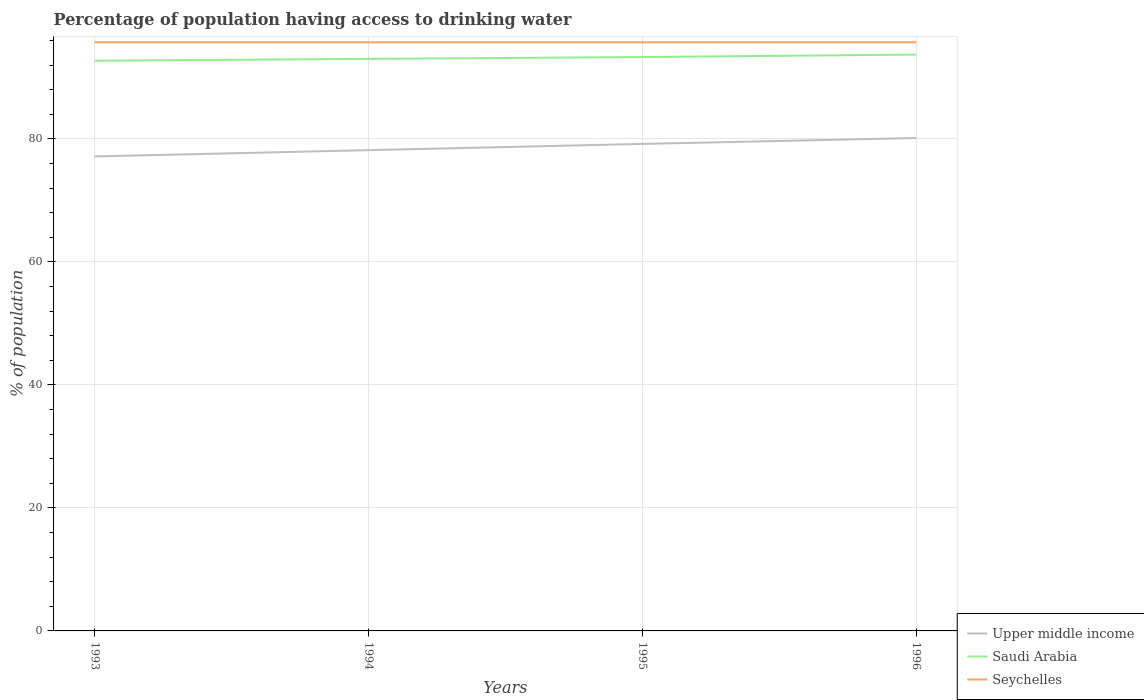How many different coloured lines are there?
Make the answer very short. 3. Across all years, what is the maximum percentage of population having access to drinking water in Saudi Arabia?
Provide a short and direct response. 92.7. What is the difference between the highest and the lowest percentage of population having access to drinking water in Upper middle income?
Provide a short and direct response. 2. What is the difference between two consecutive major ticks on the Y-axis?
Make the answer very short. 20. Does the graph contain any zero values?
Keep it short and to the point. No. Does the graph contain grids?
Ensure brevity in your answer.  Yes. Where does the legend appear in the graph?
Provide a short and direct response. Bottom right. How are the legend labels stacked?
Your answer should be compact. Vertical. What is the title of the graph?
Ensure brevity in your answer.  Percentage of population having access to drinking water. Does "Euro area" appear as one of the legend labels in the graph?
Provide a short and direct response. No. What is the label or title of the X-axis?
Offer a terse response. Years. What is the label or title of the Y-axis?
Your response must be concise. % of population. What is the % of population of Upper middle income in 1993?
Offer a terse response. 77.14. What is the % of population in Saudi Arabia in 1993?
Provide a short and direct response. 92.7. What is the % of population of Seychelles in 1993?
Give a very brief answer. 95.7. What is the % of population of Upper middle income in 1994?
Your response must be concise. 78.17. What is the % of population in Saudi Arabia in 1994?
Provide a short and direct response. 93. What is the % of population of Seychelles in 1994?
Your answer should be compact. 95.7. What is the % of population of Upper middle income in 1995?
Ensure brevity in your answer.  79.18. What is the % of population in Saudi Arabia in 1995?
Ensure brevity in your answer.  93.3. What is the % of population in Seychelles in 1995?
Provide a succinct answer. 95.7. What is the % of population in Upper middle income in 1996?
Provide a short and direct response. 80.14. What is the % of population in Saudi Arabia in 1996?
Your answer should be compact. 93.7. What is the % of population of Seychelles in 1996?
Offer a terse response. 95.7. Across all years, what is the maximum % of population of Upper middle income?
Give a very brief answer. 80.14. Across all years, what is the maximum % of population of Saudi Arabia?
Offer a terse response. 93.7. Across all years, what is the maximum % of population of Seychelles?
Your response must be concise. 95.7. Across all years, what is the minimum % of population of Upper middle income?
Provide a succinct answer. 77.14. Across all years, what is the minimum % of population in Saudi Arabia?
Your answer should be very brief. 92.7. Across all years, what is the minimum % of population in Seychelles?
Offer a terse response. 95.7. What is the total % of population in Upper middle income in the graph?
Offer a terse response. 314.62. What is the total % of population of Saudi Arabia in the graph?
Make the answer very short. 372.7. What is the total % of population in Seychelles in the graph?
Make the answer very short. 382.8. What is the difference between the % of population in Upper middle income in 1993 and that in 1994?
Your response must be concise. -1.03. What is the difference between the % of population of Seychelles in 1993 and that in 1994?
Provide a succinct answer. 0. What is the difference between the % of population of Upper middle income in 1993 and that in 1995?
Make the answer very short. -2.04. What is the difference between the % of population of Upper middle income in 1993 and that in 1996?
Offer a terse response. -3. What is the difference between the % of population in Seychelles in 1993 and that in 1996?
Provide a succinct answer. 0. What is the difference between the % of population of Upper middle income in 1994 and that in 1995?
Provide a succinct answer. -1.01. What is the difference between the % of population of Upper middle income in 1994 and that in 1996?
Provide a short and direct response. -1.97. What is the difference between the % of population in Saudi Arabia in 1994 and that in 1996?
Your answer should be compact. -0.7. What is the difference between the % of population in Upper middle income in 1995 and that in 1996?
Your answer should be very brief. -0.96. What is the difference between the % of population of Saudi Arabia in 1995 and that in 1996?
Ensure brevity in your answer.  -0.4. What is the difference between the % of population of Seychelles in 1995 and that in 1996?
Offer a terse response. 0. What is the difference between the % of population of Upper middle income in 1993 and the % of population of Saudi Arabia in 1994?
Ensure brevity in your answer.  -15.86. What is the difference between the % of population in Upper middle income in 1993 and the % of population in Seychelles in 1994?
Offer a very short reply. -18.56. What is the difference between the % of population of Saudi Arabia in 1993 and the % of population of Seychelles in 1994?
Make the answer very short. -3. What is the difference between the % of population in Upper middle income in 1993 and the % of population in Saudi Arabia in 1995?
Keep it short and to the point. -16.16. What is the difference between the % of population of Upper middle income in 1993 and the % of population of Seychelles in 1995?
Offer a terse response. -18.56. What is the difference between the % of population of Upper middle income in 1993 and the % of population of Saudi Arabia in 1996?
Ensure brevity in your answer.  -16.56. What is the difference between the % of population of Upper middle income in 1993 and the % of population of Seychelles in 1996?
Your answer should be compact. -18.56. What is the difference between the % of population in Saudi Arabia in 1993 and the % of population in Seychelles in 1996?
Make the answer very short. -3. What is the difference between the % of population in Upper middle income in 1994 and the % of population in Saudi Arabia in 1995?
Offer a terse response. -15.13. What is the difference between the % of population in Upper middle income in 1994 and the % of population in Seychelles in 1995?
Give a very brief answer. -17.53. What is the difference between the % of population of Upper middle income in 1994 and the % of population of Saudi Arabia in 1996?
Make the answer very short. -15.53. What is the difference between the % of population of Upper middle income in 1994 and the % of population of Seychelles in 1996?
Your response must be concise. -17.53. What is the difference between the % of population of Upper middle income in 1995 and the % of population of Saudi Arabia in 1996?
Make the answer very short. -14.52. What is the difference between the % of population in Upper middle income in 1995 and the % of population in Seychelles in 1996?
Provide a succinct answer. -16.52. What is the average % of population of Upper middle income per year?
Your response must be concise. 78.65. What is the average % of population in Saudi Arabia per year?
Ensure brevity in your answer.  93.17. What is the average % of population of Seychelles per year?
Your answer should be compact. 95.7. In the year 1993, what is the difference between the % of population in Upper middle income and % of population in Saudi Arabia?
Give a very brief answer. -15.56. In the year 1993, what is the difference between the % of population in Upper middle income and % of population in Seychelles?
Keep it short and to the point. -18.56. In the year 1994, what is the difference between the % of population in Upper middle income and % of population in Saudi Arabia?
Provide a short and direct response. -14.83. In the year 1994, what is the difference between the % of population in Upper middle income and % of population in Seychelles?
Your answer should be compact. -17.53. In the year 1995, what is the difference between the % of population in Upper middle income and % of population in Saudi Arabia?
Keep it short and to the point. -14.12. In the year 1995, what is the difference between the % of population in Upper middle income and % of population in Seychelles?
Make the answer very short. -16.52. In the year 1996, what is the difference between the % of population of Upper middle income and % of population of Saudi Arabia?
Make the answer very short. -13.56. In the year 1996, what is the difference between the % of population of Upper middle income and % of population of Seychelles?
Make the answer very short. -15.56. In the year 1996, what is the difference between the % of population of Saudi Arabia and % of population of Seychelles?
Provide a short and direct response. -2. What is the ratio of the % of population of Upper middle income in 1993 to that in 1994?
Your answer should be very brief. 0.99. What is the ratio of the % of population of Seychelles in 1993 to that in 1994?
Keep it short and to the point. 1. What is the ratio of the % of population of Upper middle income in 1993 to that in 1995?
Your response must be concise. 0.97. What is the ratio of the % of population in Saudi Arabia in 1993 to that in 1995?
Your answer should be compact. 0.99. What is the ratio of the % of population of Upper middle income in 1993 to that in 1996?
Offer a terse response. 0.96. What is the ratio of the % of population in Saudi Arabia in 1993 to that in 1996?
Give a very brief answer. 0.99. What is the ratio of the % of population in Upper middle income in 1994 to that in 1995?
Provide a succinct answer. 0.99. What is the ratio of the % of population of Seychelles in 1994 to that in 1995?
Offer a terse response. 1. What is the ratio of the % of population of Upper middle income in 1994 to that in 1996?
Give a very brief answer. 0.98. What is the ratio of the % of population of Saudi Arabia in 1994 to that in 1996?
Your response must be concise. 0.99. What is the ratio of the % of population of Seychelles in 1994 to that in 1996?
Ensure brevity in your answer.  1. What is the ratio of the % of population of Upper middle income in 1995 to that in 1996?
Provide a short and direct response. 0.99. What is the difference between the highest and the second highest % of population of Upper middle income?
Keep it short and to the point. 0.96. What is the difference between the highest and the second highest % of population of Saudi Arabia?
Provide a succinct answer. 0.4. What is the difference between the highest and the second highest % of population of Seychelles?
Your answer should be compact. 0. What is the difference between the highest and the lowest % of population in Upper middle income?
Provide a short and direct response. 3. What is the difference between the highest and the lowest % of population of Saudi Arabia?
Provide a succinct answer. 1. What is the difference between the highest and the lowest % of population in Seychelles?
Your answer should be compact. 0. 